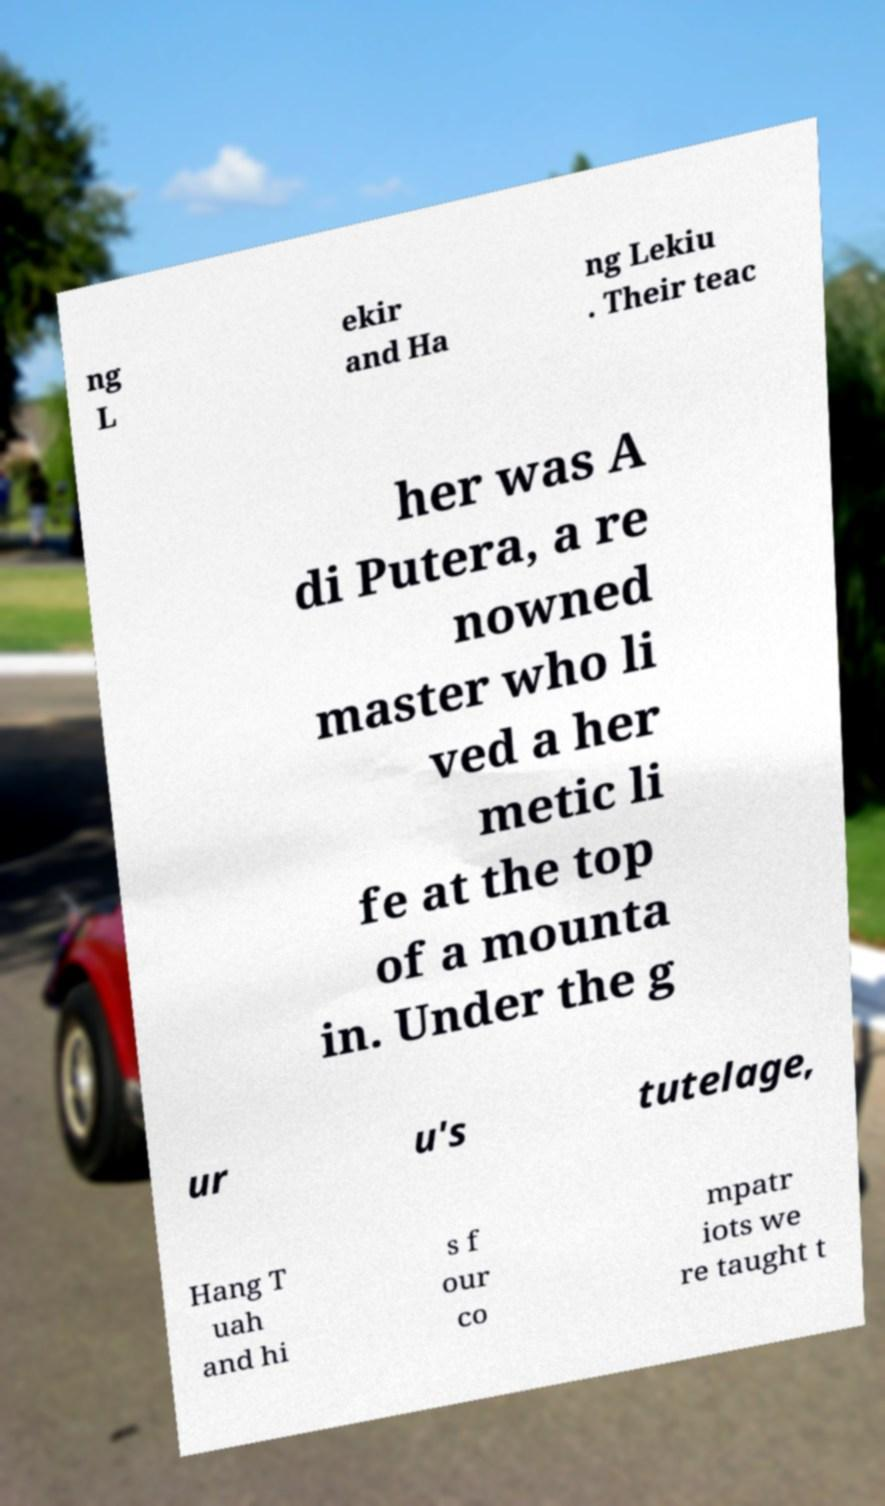Can you accurately transcribe the text from the provided image for me? ng L ekir and Ha ng Lekiu . Their teac her was A di Putera, a re nowned master who li ved a her metic li fe at the top of a mounta in. Under the g ur u's tutelage, Hang T uah and hi s f our co mpatr iots we re taught t 